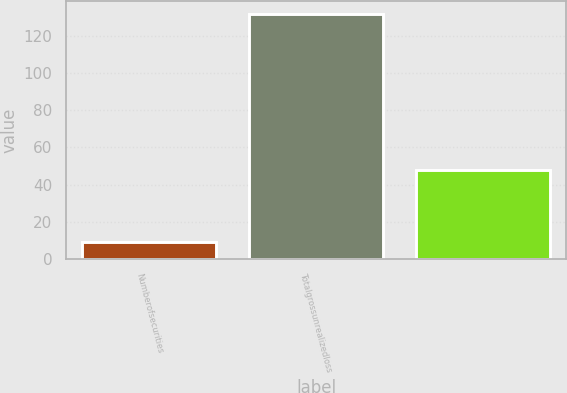<chart> <loc_0><loc_0><loc_500><loc_500><bar_chart><fcel>Numberofsecurities<fcel>Totalgrossunrealizedloss<fcel>Unnamed: 2<nl><fcel>9<fcel>132<fcel>48<nl></chart> 